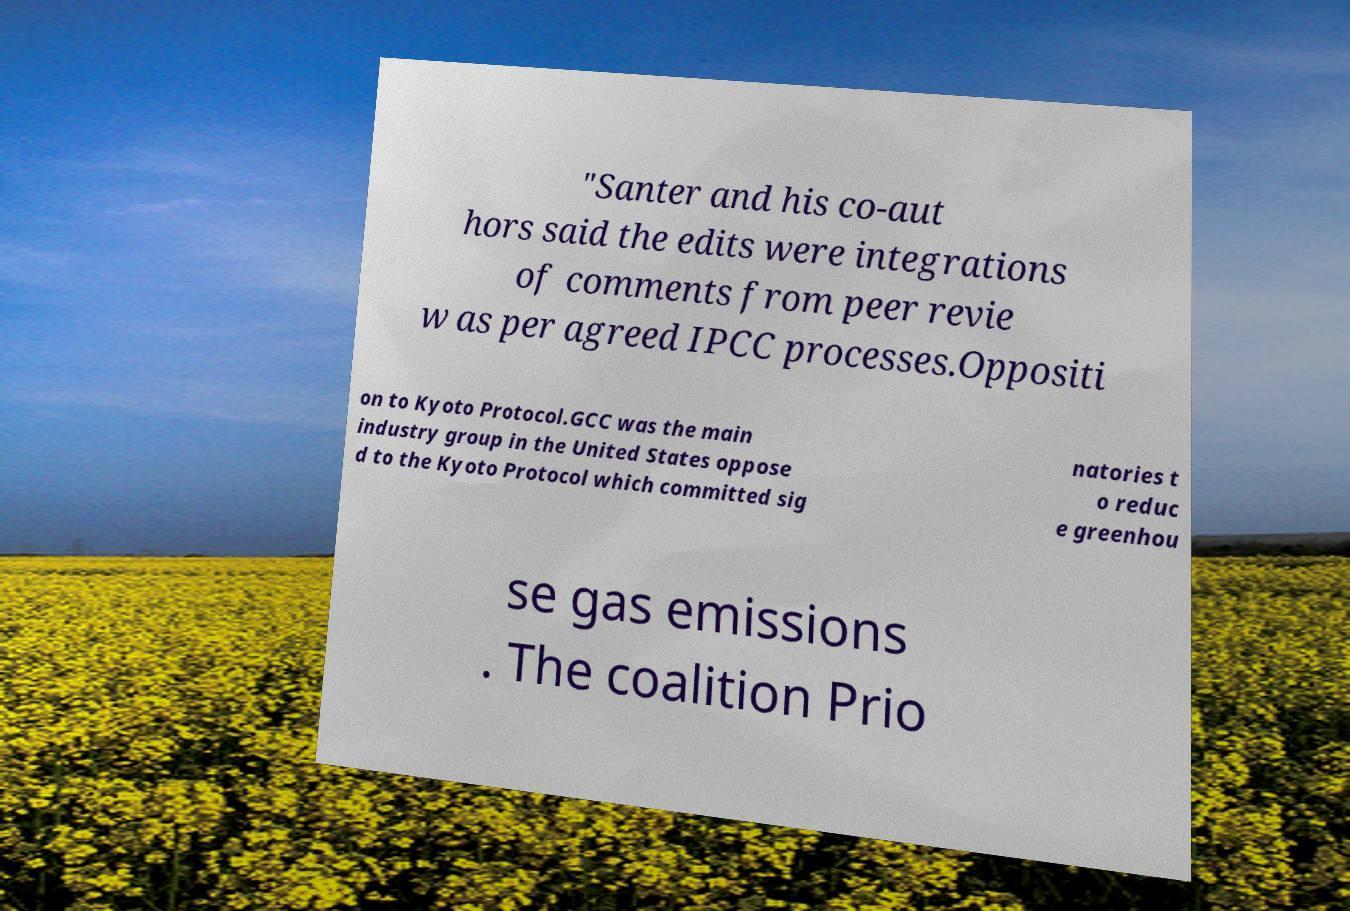I need the written content from this picture converted into text. Can you do that? "Santer and his co-aut hors said the edits were integrations of comments from peer revie w as per agreed IPCC processes.Oppositi on to Kyoto Protocol.GCC was the main industry group in the United States oppose d to the Kyoto Protocol which committed sig natories t o reduc e greenhou se gas emissions . The coalition Prio 